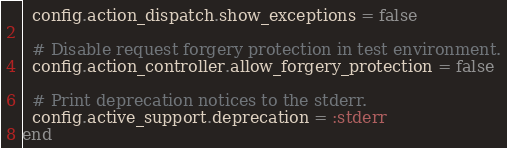Convert code to text. <code><loc_0><loc_0><loc_500><loc_500><_Ruby_>  config.action_dispatch.show_exceptions = false

  # Disable request forgery protection in test environment.
  config.action_controller.allow_forgery_protection = false

  # Print deprecation notices to the stderr.
  config.active_support.deprecation = :stderr
end
</code> 